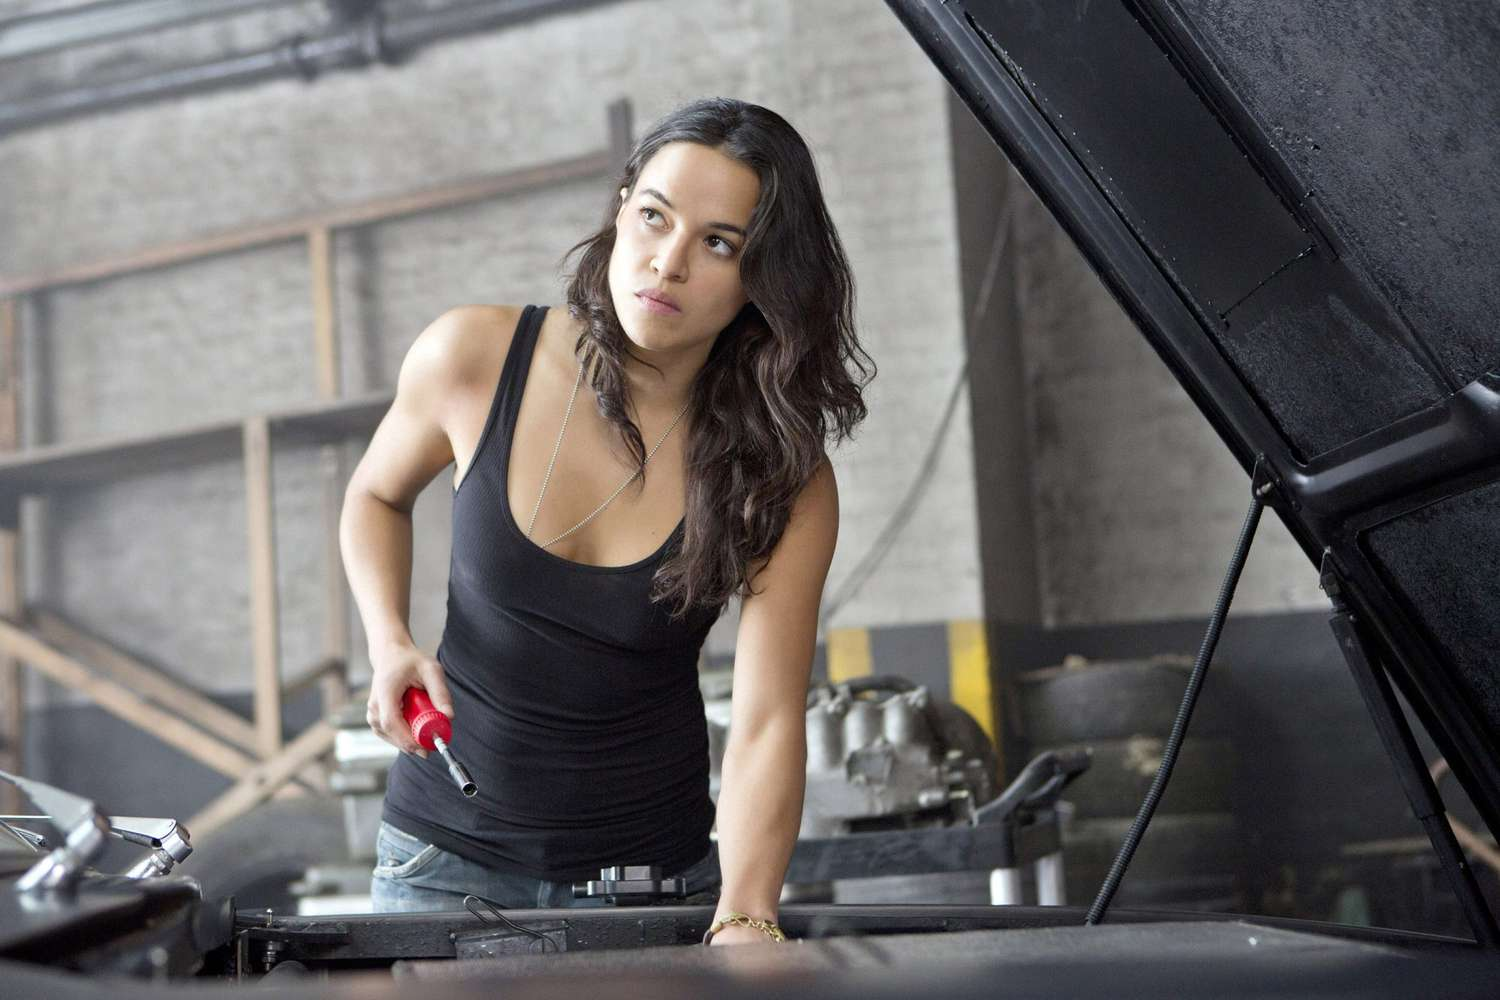If this were a scene from a movie, what might be happening in this moment? In a movie, this scene could be a pivotal moment where the character is working against the clock to repair or upgrade her car before a crucial event. The montage might show close-ups of tightening bolts, connecting wires, and checking pressure gauges, all while a tense soundtrack underscores the urgency. This meticulous preparation is critical to the upcoming challenge, whether it be a race, a heist, or an escape. The scene sets forth her mechanical prowess and determination to beat the odds, further developing her character’s depth and resilience. 